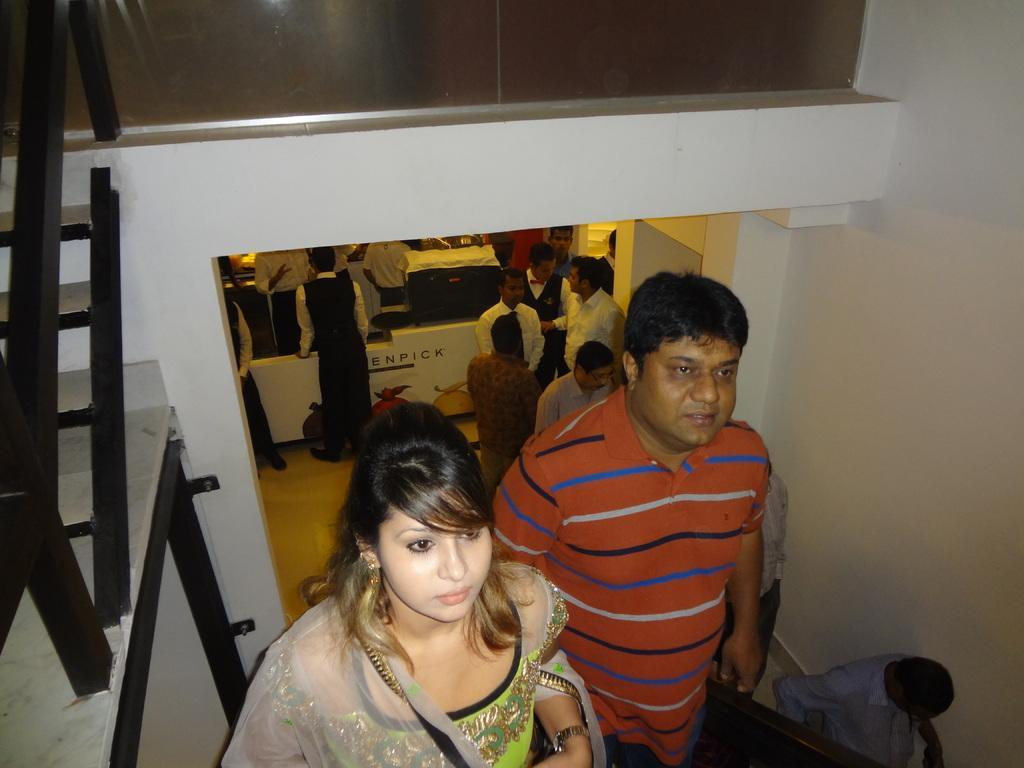What are the people in the image doing? The people in the image are climbing stairs. What can be seen in the background of the image? In the background, there are people standing near tables. What is visible behind the people in the image? There is a wall visible in the background of the image. What type of cactus can be seen on the tables in the image? There are no cacti present in the image. 